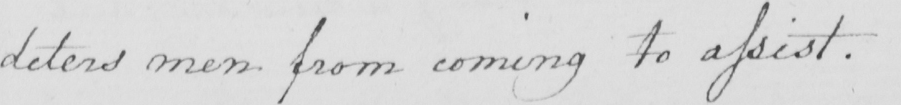Can you read and transcribe this handwriting? deters men from coming to assist . 